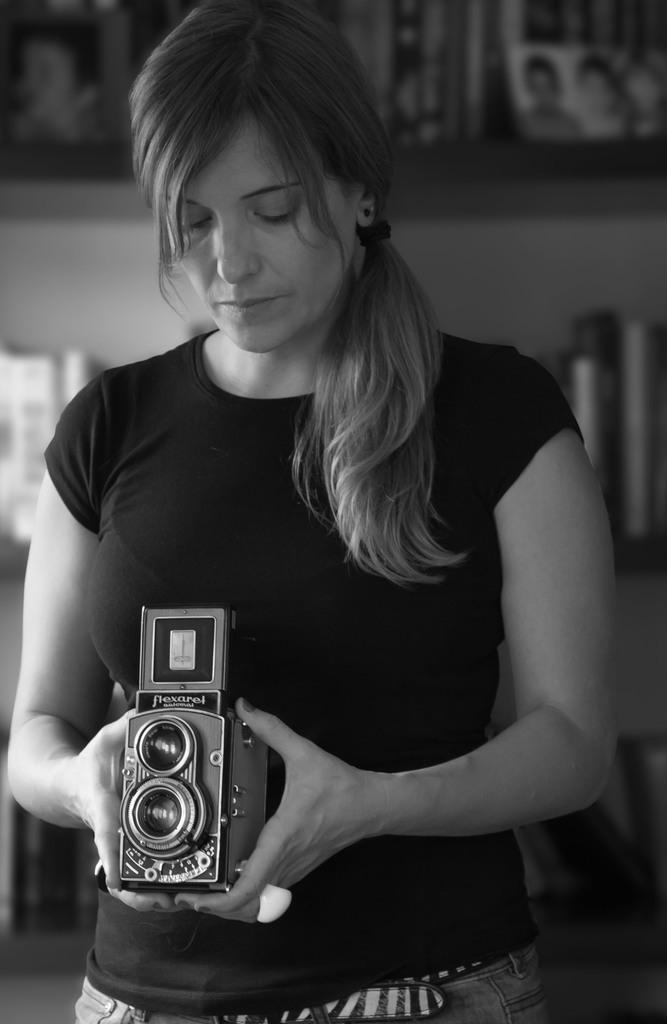Who is the main subject in the image? There is a woman in the image. What is the woman wearing? The woman is wearing a black t-shirt. What is the woman holding in the image? The woman is holding a camera. What can be seen in the background of the image? There are photos and containers in a rack in the background of the image. What type of rod is the woman using to take photos in the image? There is no rod present in the image; the woman is holding a camera to take photos. Can you see a dog in the image? No, there is no dog present in the image. 